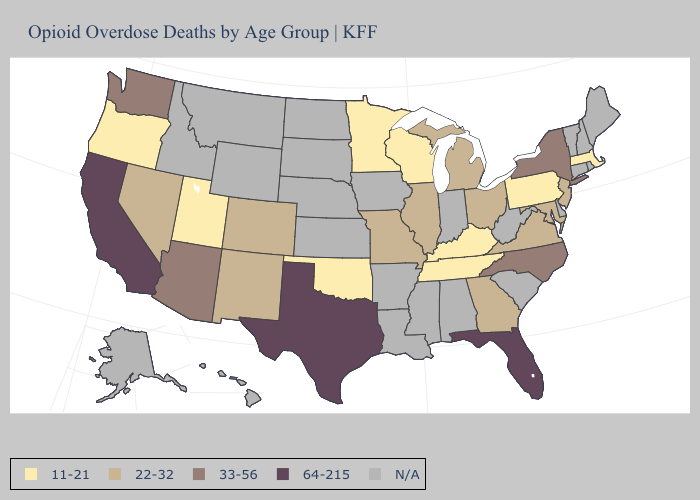What is the highest value in states that border Texas?
Be succinct. 22-32. How many symbols are there in the legend?
Keep it brief. 5. Does Wisconsin have the lowest value in the USA?
Concise answer only. Yes. What is the lowest value in states that border Delaware?
Keep it brief. 11-21. Name the states that have a value in the range 33-56?
Give a very brief answer. Arizona, New York, North Carolina, Washington. Name the states that have a value in the range 33-56?
Write a very short answer. Arizona, New York, North Carolina, Washington. What is the value of Kansas?
Answer briefly. N/A. Does Georgia have the highest value in the USA?
Answer briefly. No. How many symbols are there in the legend?
Quick response, please. 5. Which states have the lowest value in the USA?
Quick response, please. Kentucky, Massachusetts, Minnesota, Oklahoma, Oregon, Pennsylvania, Tennessee, Utah, Wisconsin. What is the value of Washington?
Short answer required. 33-56. Among the states that border Michigan , does Ohio have the lowest value?
Write a very short answer. No. What is the value of Arkansas?
Write a very short answer. N/A. Does Illinois have the lowest value in the MidWest?
Answer briefly. No. 